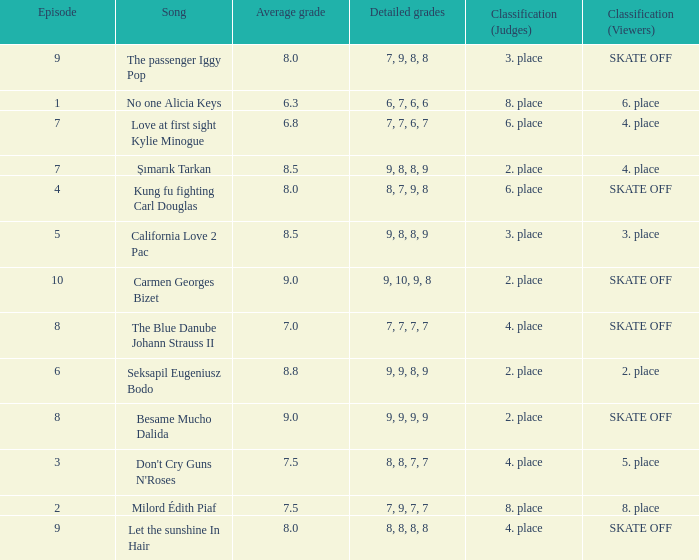Name the classification for 9, 9, 8, 9 2. place. 